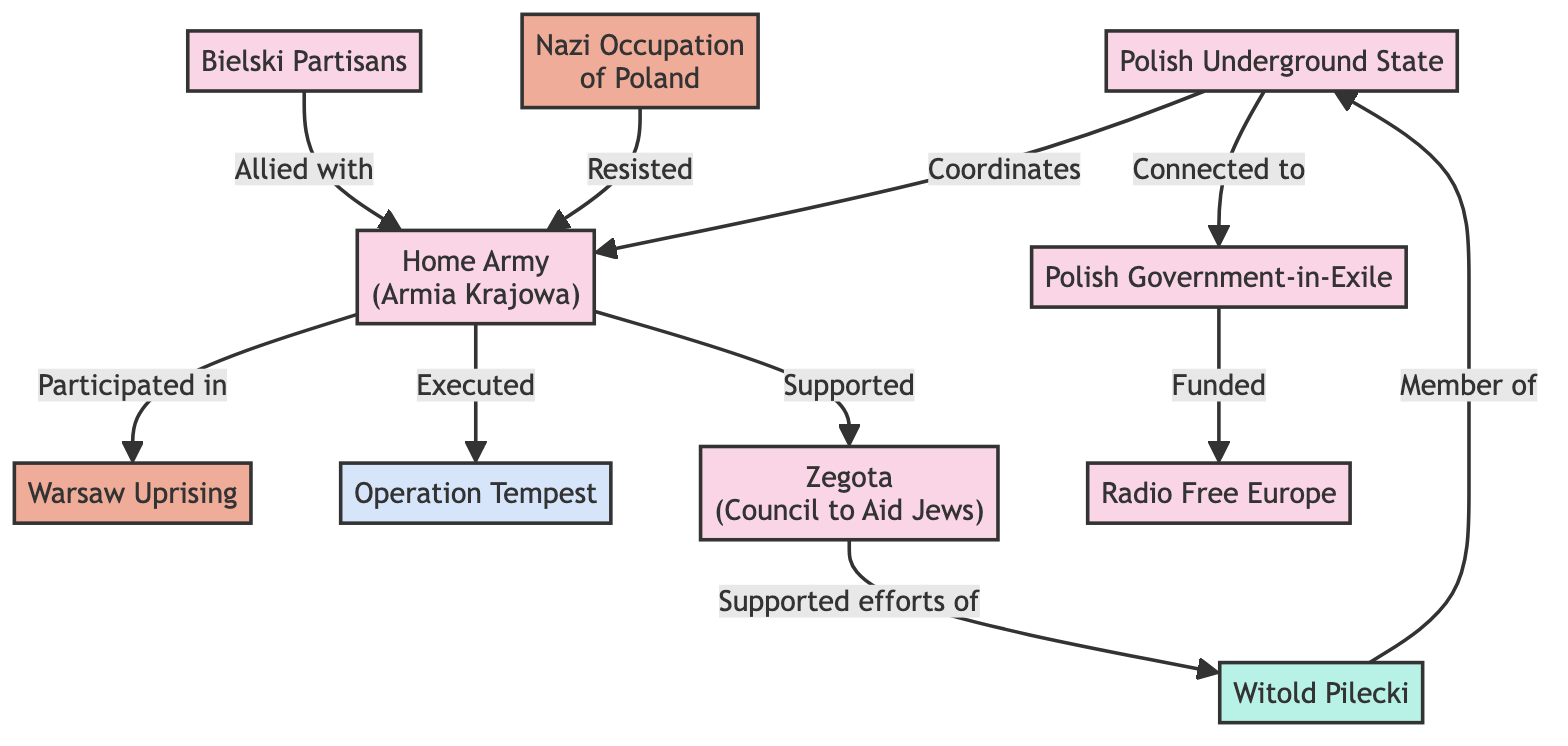What is the total number of nodes in the diagram? The diagram contains nodes representing various organizations, events, operations, and people. Counting these nodes, I find there are 10 in total.
Answer: 10 Which organization did the Home Army support? From the diagram, it shows that the Home Army supported Zegota (Council to Aid Jews) based on the edge connecting them with the label "Supported".
Answer: Zegota (Council to Aid Jews) How many organizations are connected to the Polish Underground State? The Polish Underground State has two connections: one to the Home Army (coordinates) and one to the Polish Government-in-Exile (connected to). Thus, there are two organizations connected to it.
Answer: 2 Who is a member of the Polish Underground State? The diagram indicates that Witold Pilecki is a member of the Polish Underground State, as shown by the edge labeled "Member of".
Answer: Witold Pilecki What is the primary event that the Home Army participated in? According to the diagram, the Home Army participated in the Warsaw Uprising, indicated by the edge labeled "Participated in".
Answer: Warsaw Uprising How is the Polish Government-in-Exile related to Radio Free Europe? The relationship is expressed through the edge which states that the Polish Government-in-Exile funded Radio Free Europe, signifying financial support.
Answer: Funded Which group was allied with the Home Army? The Bielski Partisans are indicated to be allied with the Home Army, as shown by the connection labeled "Allied with".
Answer: Bielski Partisans What event did the Home Army resist against? The diagram clearly states that the Home Army resisted the Nazi Occupation of Poland, reflected in the relationship labeled "Resisted".
Answer: Nazi Occupation of Poland What was Witold Pilecki's role in relation to Zegota? The diagram shows that Zegota supported the efforts of Witold Pilecki, meaning he received assistance in his endeavors.
Answer: Supported efforts of 